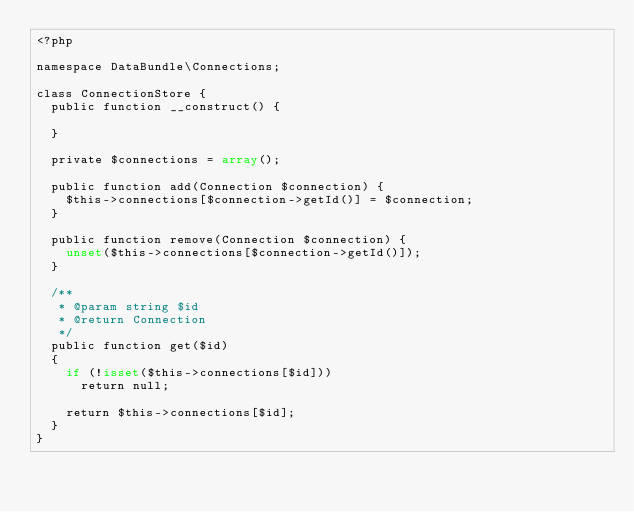Convert code to text. <code><loc_0><loc_0><loc_500><loc_500><_PHP_><?php

namespace DataBundle\Connections;

class ConnectionStore {
	public function __construct() {
		
	}
	
	private $connections = array();
	
	public function add(Connection $connection) {
		$this->connections[$connection->getId()] = $connection;
	}
	
	public function remove(Connection $connection) {
		unset($this->connections[$connection->getId()]);
	}
	
	/**
	 * @param string $id
	 * @return Connection
	 */
	public function get($id)
	{
		if (!isset($this->connections[$id]))
			return null;
		
		return $this->connections[$id];
	}
}</code> 